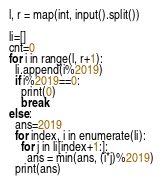<code> <loc_0><loc_0><loc_500><loc_500><_Python_>l, r = map(int, input().split())

li=[]
cnt=0
for i in range(l, r+1):
  li.append(i%2019)
  if i%2019==0:
    print(0)
    break
else:
  ans=2019
  for index, i in enumerate(li):
    for j in li[index+1:]:
      ans = min(ans, (i*j)%2019)
  print(ans)</code> 